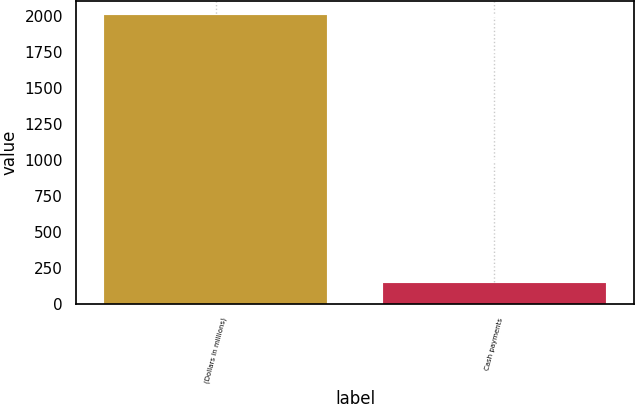Convert chart. <chart><loc_0><loc_0><loc_500><loc_500><bar_chart><fcel>(Dollars in millions)<fcel>Cash payments<nl><fcel>2006<fcel>144<nl></chart> 